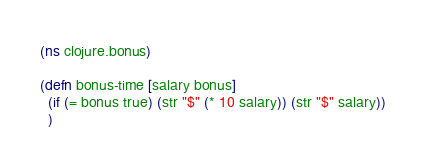Convert code to text. <code><loc_0><loc_0><loc_500><loc_500><_Clojure_>(ns clojure.bonus)

(defn bonus-time [salary bonus]
  (if (= bonus true) (str "$" (* 10 salary)) (str "$" salary))
  )</code> 